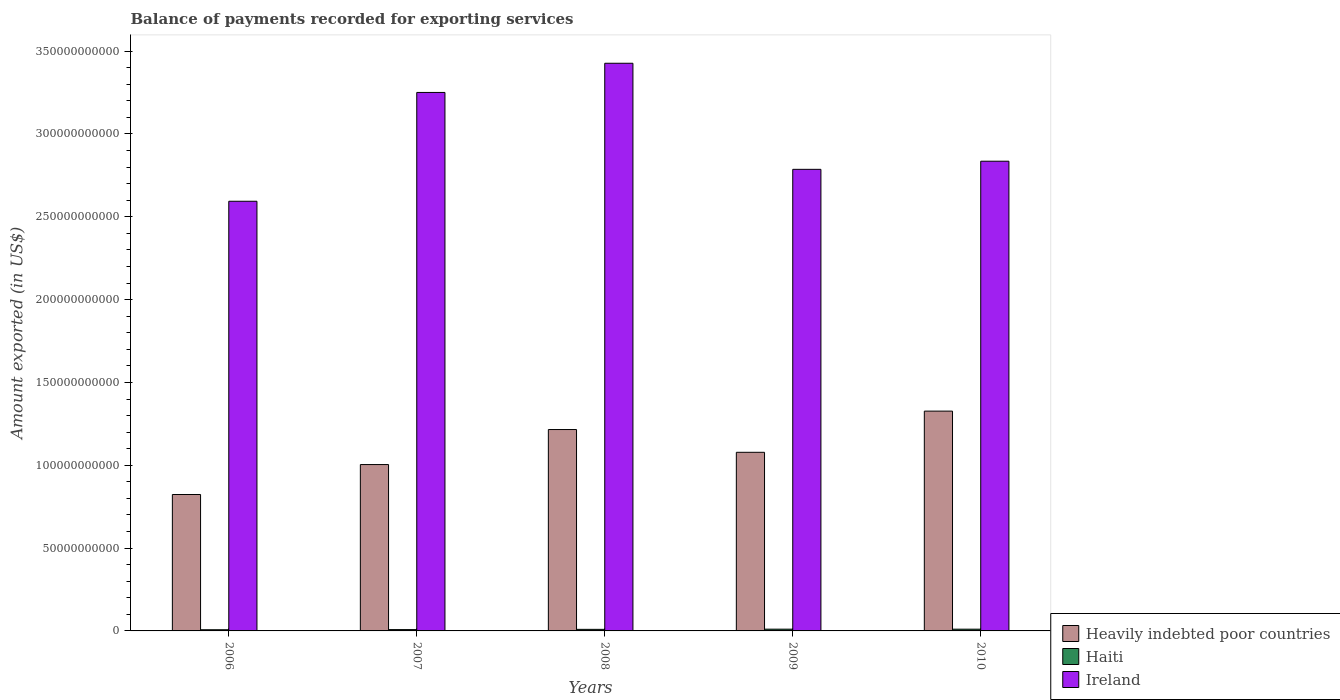How many different coloured bars are there?
Offer a very short reply. 3. How many groups of bars are there?
Give a very brief answer. 5. Are the number of bars per tick equal to the number of legend labels?
Offer a very short reply. Yes. Are the number of bars on each tick of the X-axis equal?
Provide a short and direct response. Yes. How many bars are there on the 5th tick from the right?
Your answer should be compact. 3. What is the amount exported in Ireland in 2008?
Provide a short and direct response. 3.43e+11. Across all years, what is the maximum amount exported in Haiti?
Your answer should be compact. 1.07e+09. Across all years, what is the minimum amount exported in Heavily indebted poor countries?
Keep it short and to the point. 8.24e+1. What is the total amount exported in Haiti in the graph?
Give a very brief answer. 4.57e+09. What is the difference between the amount exported in Heavily indebted poor countries in 2008 and that in 2009?
Keep it short and to the point. 1.37e+1. What is the difference between the amount exported in Haiti in 2010 and the amount exported in Heavily indebted poor countries in 2006?
Ensure brevity in your answer.  -8.13e+1. What is the average amount exported in Ireland per year?
Provide a succinct answer. 2.98e+11. In the year 2007, what is the difference between the amount exported in Ireland and amount exported in Heavily indebted poor countries?
Make the answer very short. 2.25e+11. What is the ratio of the amount exported in Haiti in 2006 to that in 2009?
Your response must be concise. 0.67. Is the difference between the amount exported in Ireland in 2007 and 2009 greater than the difference between the amount exported in Heavily indebted poor countries in 2007 and 2009?
Ensure brevity in your answer.  Yes. What is the difference between the highest and the second highest amount exported in Ireland?
Provide a short and direct response. 1.76e+1. What is the difference between the highest and the lowest amount exported in Ireland?
Your answer should be compact. 8.33e+1. Is the sum of the amount exported in Ireland in 2008 and 2010 greater than the maximum amount exported in Haiti across all years?
Your answer should be compact. Yes. What does the 1st bar from the left in 2009 represents?
Your answer should be very brief. Heavily indebted poor countries. What does the 3rd bar from the right in 2007 represents?
Offer a very short reply. Heavily indebted poor countries. How many bars are there?
Your answer should be compact. 15. Are all the bars in the graph horizontal?
Keep it short and to the point. No. Are the values on the major ticks of Y-axis written in scientific E-notation?
Your response must be concise. No. Does the graph contain any zero values?
Ensure brevity in your answer.  No. Does the graph contain grids?
Your answer should be compact. No. How many legend labels are there?
Provide a short and direct response. 3. How are the legend labels stacked?
Offer a terse response. Vertical. What is the title of the graph?
Make the answer very short. Balance of payments recorded for exporting services. What is the label or title of the X-axis?
Your answer should be compact. Years. What is the label or title of the Y-axis?
Provide a short and direct response. Amount exported (in US$). What is the Amount exported (in US$) in Heavily indebted poor countries in 2006?
Keep it short and to the point. 8.24e+1. What is the Amount exported (in US$) of Haiti in 2006?
Provide a short and direct response. 7.10e+08. What is the Amount exported (in US$) of Ireland in 2006?
Your answer should be compact. 2.59e+11. What is the Amount exported (in US$) in Heavily indebted poor countries in 2007?
Offer a very short reply. 1.00e+11. What is the Amount exported (in US$) of Haiti in 2007?
Provide a succinct answer. 8.01e+08. What is the Amount exported (in US$) in Ireland in 2007?
Ensure brevity in your answer.  3.25e+11. What is the Amount exported (in US$) of Heavily indebted poor countries in 2008?
Offer a very short reply. 1.22e+11. What is the Amount exported (in US$) of Haiti in 2008?
Provide a succinct answer. 9.45e+08. What is the Amount exported (in US$) in Ireland in 2008?
Make the answer very short. 3.43e+11. What is the Amount exported (in US$) of Heavily indebted poor countries in 2009?
Keep it short and to the point. 1.08e+11. What is the Amount exported (in US$) in Haiti in 2009?
Provide a succinct answer. 1.07e+09. What is the Amount exported (in US$) of Ireland in 2009?
Your answer should be compact. 2.79e+11. What is the Amount exported (in US$) in Heavily indebted poor countries in 2010?
Offer a very short reply. 1.33e+11. What is the Amount exported (in US$) in Haiti in 2010?
Provide a succinct answer. 1.05e+09. What is the Amount exported (in US$) in Ireland in 2010?
Make the answer very short. 2.84e+11. Across all years, what is the maximum Amount exported (in US$) in Heavily indebted poor countries?
Make the answer very short. 1.33e+11. Across all years, what is the maximum Amount exported (in US$) in Haiti?
Ensure brevity in your answer.  1.07e+09. Across all years, what is the maximum Amount exported (in US$) of Ireland?
Offer a terse response. 3.43e+11. Across all years, what is the minimum Amount exported (in US$) of Heavily indebted poor countries?
Make the answer very short. 8.24e+1. Across all years, what is the minimum Amount exported (in US$) in Haiti?
Offer a terse response. 7.10e+08. Across all years, what is the minimum Amount exported (in US$) in Ireland?
Your answer should be very brief. 2.59e+11. What is the total Amount exported (in US$) in Heavily indebted poor countries in the graph?
Provide a short and direct response. 5.45e+11. What is the total Amount exported (in US$) in Haiti in the graph?
Your response must be concise. 4.57e+09. What is the total Amount exported (in US$) in Ireland in the graph?
Keep it short and to the point. 1.49e+12. What is the difference between the Amount exported (in US$) in Heavily indebted poor countries in 2006 and that in 2007?
Your response must be concise. -1.81e+1. What is the difference between the Amount exported (in US$) in Haiti in 2006 and that in 2007?
Provide a succinct answer. -9.10e+07. What is the difference between the Amount exported (in US$) in Ireland in 2006 and that in 2007?
Offer a terse response. -6.57e+1. What is the difference between the Amount exported (in US$) in Heavily indebted poor countries in 2006 and that in 2008?
Your answer should be very brief. -3.92e+1. What is the difference between the Amount exported (in US$) in Haiti in 2006 and that in 2008?
Give a very brief answer. -2.35e+08. What is the difference between the Amount exported (in US$) of Ireland in 2006 and that in 2008?
Ensure brevity in your answer.  -8.33e+1. What is the difference between the Amount exported (in US$) in Heavily indebted poor countries in 2006 and that in 2009?
Give a very brief answer. -2.55e+1. What is the difference between the Amount exported (in US$) in Haiti in 2006 and that in 2009?
Give a very brief answer. -3.55e+08. What is the difference between the Amount exported (in US$) in Ireland in 2006 and that in 2009?
Ensure brevity in your answer.  -1.93e+1. What is the difference between the Amount exported (in US$) of Heavily indebted poor countries in 2006 and that in 2010?
Give a very brief answer. -5.03e+1. What is the difference between the Amount exported (in US$) of Haiti in 2006 and that in 2010?
Offer a very short reply. -3.39e+08. What is the difference between the Amount exported (in US$) of Ireland in 2006 and that in 2010?
Give a very brief answer. -2.42e+1. What is the difference between the Amount exported (in US$) in Heavily indebted poor countries in 2007 and that in 2008?
Offer a very short reply. -2.11e+1. What is the difference between the Amount exported (in US$) in Haiti in 2007 and that in 2008?
Your answer should be very brief. -1.44e+08. What is the difference between the Amount exported (in US$) in Ireland in 2007 and that in 2008?
Ensure brevity in your answer.  -1.76e+1. What is the difference between the Amount exported (in US$) of Heavily indebted poor countries in 2007 and that in 2009?
Make the answer very short. -7.40e+09. What is the difference between the Amount exported (in US$) of Haiti in 2007 and that in 2009?
Make the answer very short. -2.64e+08. What is the difference between the Amount exported (in US$) of Ireland in 2007 and that in 2009?
Provide a succinct answer. 4.64e+1. What is the difference between the Amount exported (in US$) of Heavily indebted poor countries in 2007 and that in 2010?
Give a very brief answer. -3.23e+1. What is the difference between the Amount exported (in US$) of Haiti in 2007 and that in 2010?
Give a very brief answer. -2.48e+08. What is the difference between the Amount exported (in US$) of Ireland in 2007 and that in 2010?
Provide a succinct answer. 4.15e+1. What is the difference between the Amount exported (in US$) in Heavily indebted poor countries in 2008 and that in 2009?
Give a very brief answer. 1.37e+1. What is the difference between the Amount exported (in US$) of Haiti in 2008 and that in 2009?
Your response must be concise. -1.20e+08. What is the difference between the Amount exported (in US$) of Ireland in 2008 and that in 2009?
Ensure brevity in your answer.  6.40e+1. What is the difference between the Amount exported (in US$) in Heavily indebted poor countries in 2008 and that in 2010?
Make the answer very short. -1.11e+1. What is the difference between the Amount exported (in US$) of Haiti in 2008 and that in 2010?
Your response must be concise. -1.04e+08. What is the difference between the Amount exported (in US$) of Ireland in 2008 and that in 2010?
Your response must be concise. 5.91e+1. What is the difference between the Amount exported (in US$) in Heavily indebted poor countries in 2009 and that in 2010?
Give a very brief answer. -2.49e+1. What is the difference between the Amount exported (in US$) in Haiti in 2009 and that in 2010?
Your answer should be very brief. 1.60e+07. What is the difference between the Amount exported (in US$) in Ireland in 2009 and that in 2010?
Your answer should be very brief. -4.91e+09. What is the difference between the Amount exported (in US$) of Heavily indebted poor countries in 2006 and the Amount exported (in US$) of Haiti in 2007?
Provide a short and direct response. 8.15e+1. What is the difference between the Amount exported (in US$) in Heavily indebted poor countries in 2006 and the Amount exported (in US$) in Ireland in 2007?
Make the answer very short. -2.43e+11. What is the difference between the Amount exported (in US$) of Haiti in 2006 and the Amount exported (in US$) of Ireland in 2007?
Offer a very short reply. -3.24e+11. What is the difference between the Amount exported (in US$) in Heavily indebted poor countries in 2006 and the Amount exported (in US$) in Haiti in 2008?
Provide a short and direct response. 8.14e+1. What is the difference between the Amount exported (in US$) of Heavily indebted poor countries in 2006 and the Amount exported (in US$) of Ireland in 2008?
Make the answer very short. -2.60e+11. What is the difference between the Amount exported (in US$) of Haiti in 2006 and the Amount exported (in US$) of Ireland in 2008?
Your answer should be very brief. -3.42e+11. What is the difference between the Amount exported (in US$) of Heavily indebted poor countries in 2006 and the Amount exported (in US$) of Haiti in 2009?
Ensure brevity in your answer.  8.13e+1. What is the difference between the Amount exported (in US$) of Heavily indebted poor countries in 2006 and the Amount exported (in US$) of Ireland in 2009?
Your answer should be compact. -1.96e+11. What is the difference between the Amount exported (in US$) in Haiti in 2006 and the Amount exported (in US$) in Ireland in 2009?
Your answer should be very brief. -2.78e+11. What is the difference between the Amount exported (in US$) in Heavily indebted poor countries in 2006 and the Amount exported (in US$) in Haiti in 2010?
Ensure brevity in your answer.  8.13e+1. What is the difference between the Amount exported (in US$) of Heavily indebted poor countries in 2006 and the Amount exported (in US$) of Ireland in 2010?
Ensure brevity in your answer.  -2.01e+11. What is the difference between the Amount exported (in US$) in Haiti in 2006 and the Amount exported (in US$) in Ireland in 2010?
Your answer should be very brief. -2.83e+11. What is the difference between the Amount exported (in US$) of Heavily indebted poor countries in 2007 and the Amount exported (in US$) of Haiti in 2008?
Give a very brief answer. 9.95e+1. What is the difference between the Amount exported (in US$) in Heavily indebted poor countries in 2007 and the Amount exported (in US$) in Ireland in 2008?
Offer a very short reply. -2.42e+11. What is the difference between the Amount exported (in US$) of Haiti in 2007 and the Amount exported (in US$) of Ireland in 2008?
Your response must be concise. -3.42e+11. What is the difference between the Amount exported (in US$) in Heavily indebted poor countries in 2007 and the Amount exported (in US$) in Haiti in 2009?
Give a very brief answer. 9.94e+1. What is the difference between the Amount exported (in US$) in Heavily indebted poor countries in 2007 and the Amount exported (in US$) in Ireland in 2009?
Offer a terse response. -1.78e+11. What is the difference between the Amount exported (in US$) in Haiti in 2007 and the Amount exported (in US$) in Ireland in 2009?
Offer a very short reply. -2.78e+11. What is the difference between the Amount exported (in US$) of Heavily indebted poor countries in 2007 and the Amount exported (in US$) of Haiti in 2010?
Keep it short and to the point. 9.94e+1. What is the difference between the Amount exported (in US$) in Heavily indebted poor countries in 2007 and the Amount exported (in US$) in Ireland in 2010?
Make the answer very short. -1.83e+11. What is the difference between the Amount exported (in US$) in Haiti in 2007 and the Amount exported (in US$) in Ireland in 2010?
Keep it short and to the point. -2.83e+11. What is the difference between the Amount exported (in US$) of Heavily indebted poor countries in 2008 and the Amount exported (in US$) of Haiti in 2009?
Keep it short and to the point. 1.21e+11. What is the difference between the Amount exported (in US$) in Heavily indebted poor countries in 2008 and the Amount exported (in US$) in Ireland in 2009?
Keep it short and to the point. -1.57e+11. What is the difference between the Amount exported (in US$) in Haiti in 2008 and the Amount exported (in US$) in Ireland in 2009?
Offer a terse response. -2.78e+11. What is the difference between the Amount exported (in US$) of Heavily indebted poor countries in 2008 and the Amount exported (in US$) of Haiti in 2010?
Provide a short and direct response. 1.21e+11. What is the difference between the Amount exported (in US$) of Heavily indebted poor countries in 2008 and the Amount exported (in US$) of Ireland in 2010?
Your answer should be compact. -1.62e+11. What is the difference between the Amount exported (in US$) in Haiti in 2008 and the Amount exported (in US$) in Ireland in 2010?
Provide a succinct answer. -2.83e+11. What is the difference between the Amount exported (in US$) of Heavily indebted poor countries in 2009 and the Amount exported (in US$) of Haiti in 2010?
Give a very brief answer. 1.07e+11. What is the difference between the Amount exported (in US$) of Heavily indebted poor countries in 2009 and the Amount exported (in US$) of Ireland in 2010?
Your answer should be compact. -1.76e+11. What is the difference between the Amount exported (in US$) of Haiti in 2009 and the Amount exported (in US$) of Ireland in 2010?
Your response must be concise. -2.82e+11. What is the average Amount exported (in US$) in Heavily indebted poor countries per year?
Provide a succinct answer. 1.09e+11. What is the average Amount exported (in US$) in Haiti per year?
Your response must be concise. 9.14e+08. What is the average Amount exported (in US$) in Ireland per year?
Your response must be concise. 2.98e+11. In the year 2006, what is the difference between the Amount exported (in US$) in Heavily indebted poor countries and Amount exported (in US$) in Haiti?
Ensure brevity in your answer.  8.16e+1. In the year 2006, what is the difference between the Amount exported (in US$) of Heavily indebted poor countries and Amount exported (in US$) of Ireland?
Offer a very short reply. -1.77e+11. In the year 2006, what is the difference between the Amount exported (in US$) in Haiti and Amount exported (in US$) in Ireland?
Make the answer very short. -2.59e+11. In the year 2007, what is the difference between the Amount exported (in US$) of Heavily indebted poor countries and Amount exported (in US$) of Haiti?
Provide a succinct answer. 9.96e+1. In the year 2007, what is the difference between the Amount exported (in US$) of Heavily indebted poor countries and Amount exported (in US$) of Ireland?
Offer a terse response. -2.25e+11. In the year 2007, what is the difference between the Amount exported (in US$) in Haiti and Amount exported (in US$) in Ireland?
Your answer should be compact. -3.24e+11. In the year 2008, what is the difference between the Amount exported (in US$) of Heavily indebted poor countries and Amount exported (in US$) of Haiti?
Give a very brief answer. 1.21e+11. In the year 2008, what is the difference between the Amount exported (in US$) in Heavily indebted poor countries and Amount exported (in US$) in Ireland?
Your answer should be compact. -2.21e+11. In the year 2008, what is the difference between the Amount exported (in US$) of Haiti and Amount exported (in US$) of Ireland?
Your answer should be very brief. -3.42e+11. In the year 2009, what is the difference between the Amount exported (in US$) in Heavily indebted poor countries and Amount exported (in US$) in Haiti?
Give a very brief answer. 1.07e+11. In the year 2009, what is the difference between the Amount exported (in US$) in Heavily indebted poor countries and Amount exported (in US$) in Ireland?
Your response must be concise. -1.71e+11. In the year 2009, what is the difference between the Amount exported (in US$) in Haiti and Amount exported (in US$) in Ireland?
Your response must be concise. -2.78e+11. In the year 2010, what is the difference between the Amount exported (in US$) in Heavily indebted poor countries and Amount exported (in US$) in Haiti?
Provide a succinct answer. 1.32e+11. In the year 2010, what is the difference between the Amount exported (in US$) in Heavily indebted poor countries and Amount exported (in US$) in Ireland?
Your answer should be compact. -1.51e+11. In the year 2010, what is the difference between the Amount exported (in US$) in Haiti and Amount exported (in US$) in Ireland?
Your answer should be very brief. -2.83e+11. What is the ratio of the Amount exported (in US$) of Heavily indebted poor countries in 2006 to that in 2007?
Make the answer very short. 0.82. What is the ratio of the Amount exported (in US$) in Haiti in 2006 to that in 2007?
Provide a short and direct response. 0.89. What is the ratio of the Amount exported (in US$) of Ireland in 2006 to that in 2007?
Ensure brevity in your answer.  0.8. What is the ratio of the Amount exported (in US$) of Heavily indebted poor countries in 2006 to that in 2008?
Your response must be concise. 0.68. What is the ratio of the Amount exported (in US$) in Haiti in 2006 to that in 2008?
Your answer should be compact. 0.75. What is the ratio of the Amount exported (in US$) in Ireland in 2006 to that in 2008?
Make the answer very short. 0.76. What is the ratio of the Amount exported (in US$) of Heavily indebted poor countries in 2006 to that in 2009?
Your answer should be compact. 0.76. What is the ratio of the Amount exported (in US$) of Haiti in 2006 to that in 2009?
Offer a very short reply. 0.67. What is the ratio of the Amount exported (in US$) in Ireland in 2006 to that in 2009?
Provide a succinct answer. 0.93. What is the ratio of the Amount exported (in US$) of Heavily indebted poor countries in 2006 to that in 2010?
Your response must be concise. 0.62. What is the ratio of the Amount exported (in US$) in Haiti in 2006 to that in 2010?
Provide a short and direct response. 0.68. What is the ratio of the Amount exported (in US$) in Ireland in 2006 to that in 2010?
Offer a terse response. 0.91. What is the ratio of the Amount exported (in US$) of Heavily indebted poor countries in 2007 to that in 2008?
Provide a short and direct response. 0.83. What is the ratio of the Amount exported (in US$) of Haiti in 2007 to that in 2008?
Your answer should be very brief. 0.85. What is the ratio of the Amount exported (in US$) in Ireland in 2007 to that in 2008?
Your answer should be compact. 0.95. What is the ratio of the Amount exported (in US$) in Heavily indebted poor countries in 2007 to that in 2009?
Offer a terse response. 0.93. What is the ratio of the Amount exported (in US$) of Haiti in 2007 to that in 2009?
Provide a succinct answer. 0.75. What is the ratio of the Amount exported (in US$) in Ireland in 2007 to that in 2009?
Your answer should be very brief. 1.17. What is the ratio of the Amount exported (in US$) in Heavily indebted poor countries in 2007 to that in 2010?
Provide a succinct answer. 0.76. What is the ratio of the Amount exported (in US$) in Haiti in 2007 to that in 2010?
Your response must be concise. 0.76. What is the ratio of the Amount exported (in US$) in Ireland in 2007 to that in 2010?
Keep it short and to the point. 1.15. What is the ratio of the Amount exported (in US$) in Heavily indebted poor countries in 2008 to that in 2009?
Offer a very short reply. 1.13. What is the ratio of the Amount exported (in US$) of Haiti in 2008 to that in 2009?
Give a very brief answer. 0.89. What is the ratio of the Amount exported (in US$) in Ireland in 2008 to that in 2009?
Your response must be concise. 1.23. What is the ratio of the Amount exported (in US$) of Heavily indebted poor countries in 2008 to that in 2010?
Your answer should be compact. 0.92. What is the ratio of the Amount exported (in US$) in Haiti in 2008 to that in 2010?
Your answer should be compact. 0.9. What is the ratio of the Amount exported (in US$) of Ireland in 2008 to that in 2010?
Offer a very short reply. 1.21. What is the ratio of the Amount exported (in US$) of Heavily indebted poor countries in 2009 to that in 2010?
Offer a terse response. 0.81. What is the ratio of the Amount exported (in US$) in Haiti in 2009 to that in 2010?
Offer a terse response. 1.02. What is the ratio of the Amount exported (in US$) of Ireland in 2009 to that in 2010?
Your answer should be very brief. 0.98. What is the difference between the highest and the second highest Amount exported (in US$) of Heavily indebted poor countries?
Offer a very short reply. 1.11e+1. What is the difference between the highest and the second highest Amount exported (in US$) of Haiti?
Offer a terse response. 1.60e+07. What is the difference between the highest and the second highest Amount exported (in US$) of Ireland?
Your answer should be very brief. 1.76e+1. What is the difference between the highest and the lowest Amount exported (in US$) in Heavily indebted poor countries?
Give a very brief answer. 5.03e+1. What is the difference between the highest and the lowest Amount exported (in US$) in Haiti?
Your answer should be compact. 3.55e+08. What is the difference between the highest and the lowest Amount exported (in US$) in Ireland?
Provide a succinct answer. 8.33e+1. 